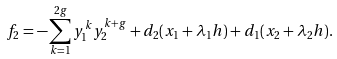Convert formula to latex. <formula><loc_0><loc_0><loc_500><loc_500>f _ { 2 } = - \sum _ { k = 1 } ^ { 2 g } y _ { 1 } ^ { k } y _ { 2 } ^ { k + g } + d _ { 2 } ( x _ { 1 } + \lambda _ { 1 } h ) + d _ { 1 } ( x _ { 2 } + \lambda _ { 2 } h ) .</formula> 